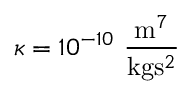<formula> <loc_0><loc_0><loc_500><loc_500>\kappa = 1 0 ^ { - 1 0 } \frac { m ^ { 7 } } { k g s ^ { 2 } }</formula> 